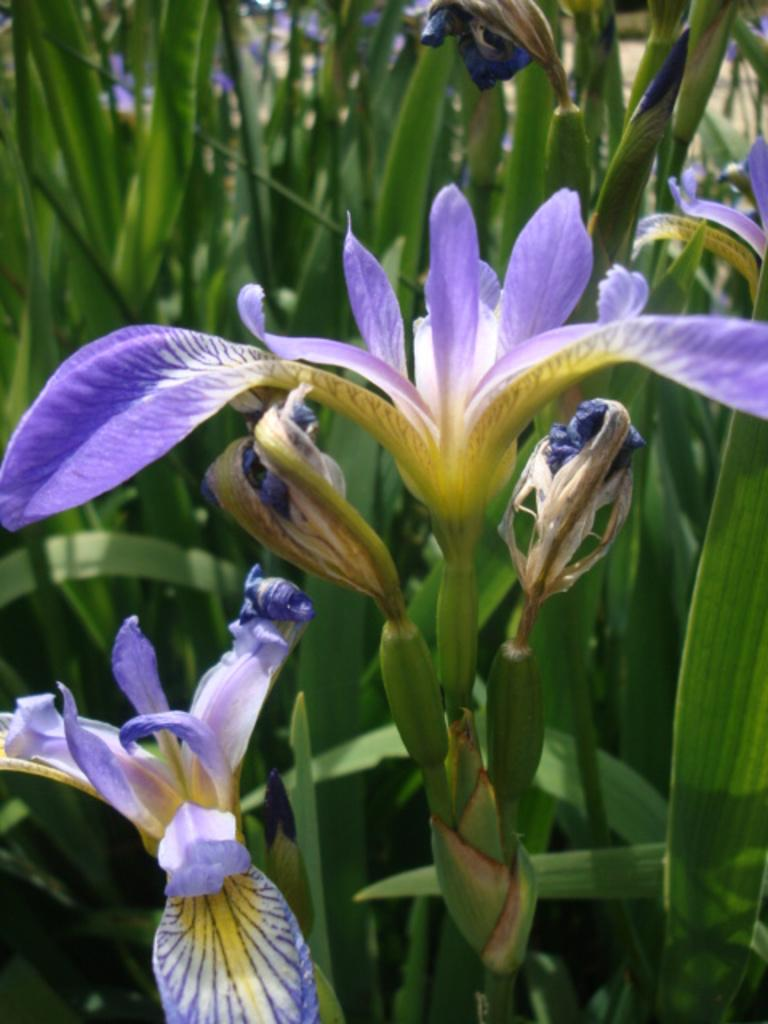What is located in the center of the image? There are plants in the center of the image. What type of plants are present in the image? There are flowers in the image. What colors can be seen in the flowers? The flowers are in violet and yellow colors. How many chickens are sitting on the list in the image? There are no chickens or lists present in the image. 